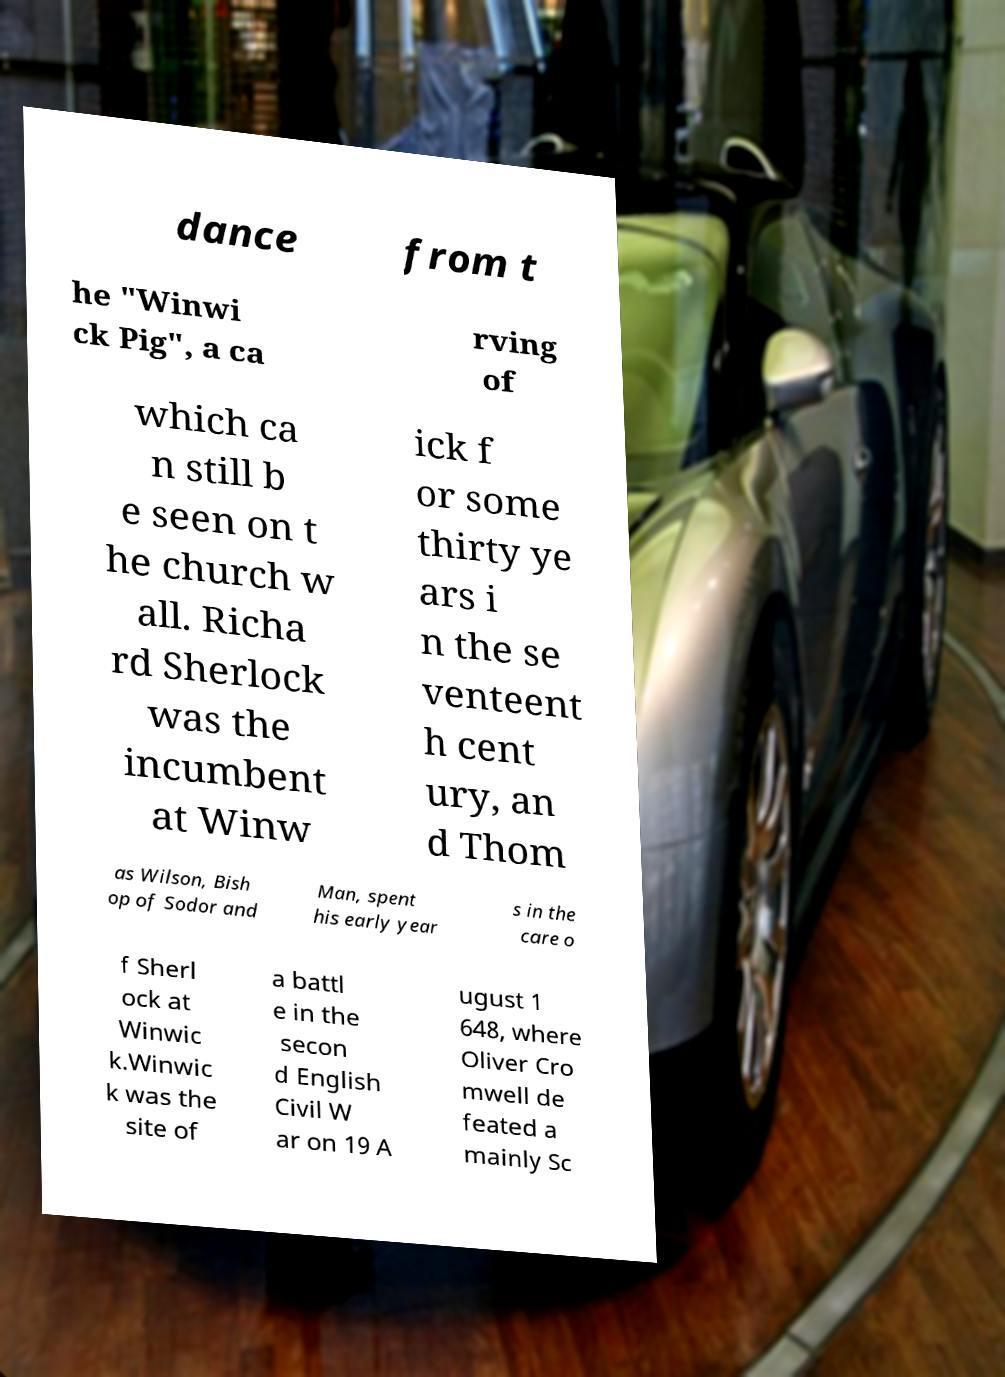Could you extract and type out the text from this image? dance from t he "Winwi ck Pig", a ca rving of which ca n still b e seen on t he church w all. Richa rd Sherlock was the incumbent at Winw ick f or some thirty ye ars i n the se venteent h cent ury, an d Thom as Wilson, Bish op of Sodor and Man, spent his early year s in the care o f Sherl ock at Winwic k.Winwic k was the site of a battl e in the secon d English Civil W ar on 19 A ugust 1 648, where Oliver Cro mwell de feated a mainly Sc 